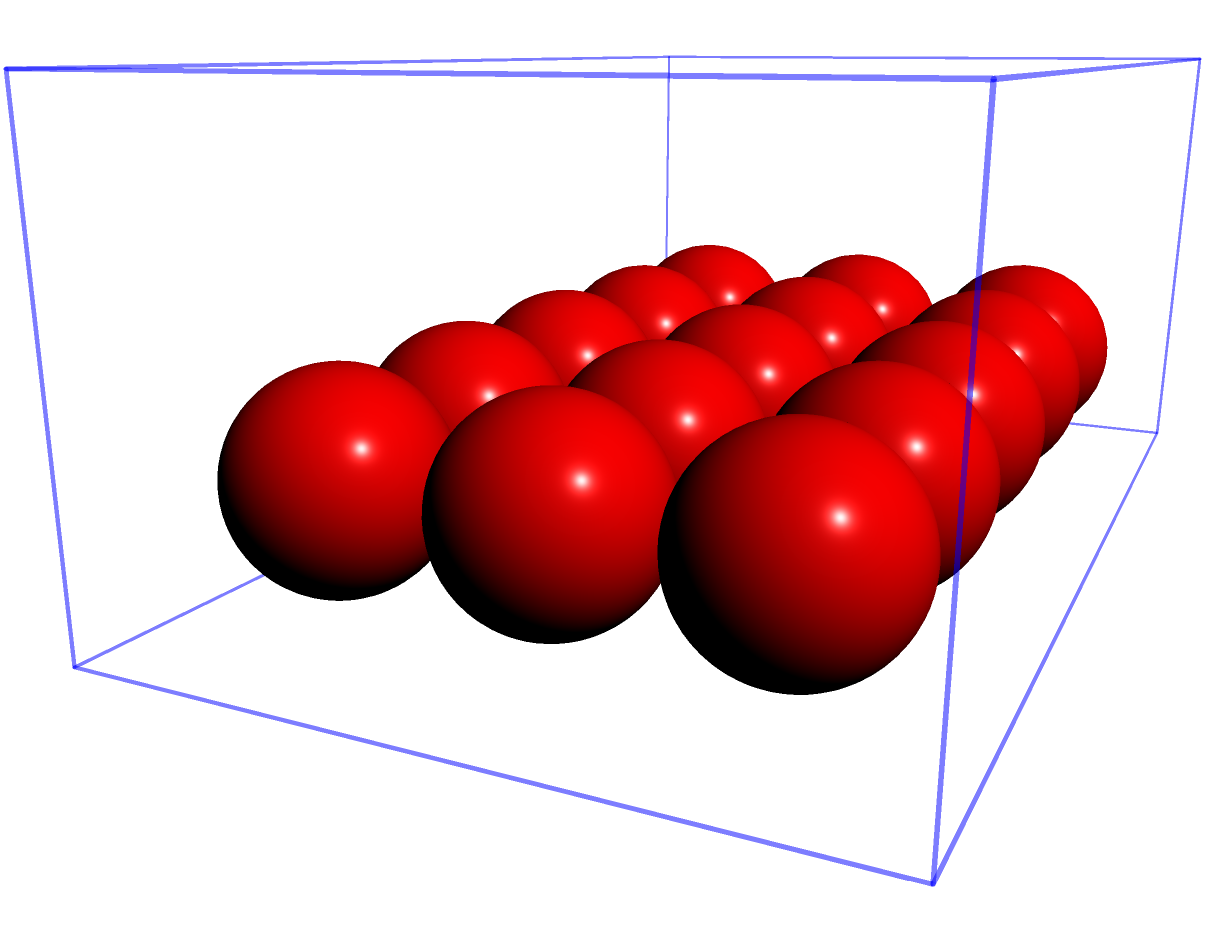You're organizing your kids' toys and have a rectangular toy box measuring 20 inches long, 12 inches wide, and 8 inches high. If each spherical toy has a diameter of 4 inches, how many of these toys can you fit into the box without stacking them on top of each other? Let's approach this step-by-step:

1. First, we need to determine how many toys can fit along each dimension of the box:

   Length: $20 \div 4 = 5$ toys
   Width: $12 \div 4 = 3$ toys
   Height: $8 \div 4 = 2$ toys (but we're not stacking, so we'll only use 1 layer)

2. Since we're not stacking the toys, we only need to calculate how many fit on the base of the box:

   Number of toys = (Toys along length) × (Toys along width)
                  = $5 \times 3 = 15$ toys

3. It's important to note that this calculation assumes perfect packing, which may not be realistic with spherical objects. In practice, there might be some space between the spheres.

4. This problem relates to your situation as a stay-at-home dad because it involves organizing children's toys efficiently, a common task in managing a household while potentially planning a small business.
Answer: 15 toys 